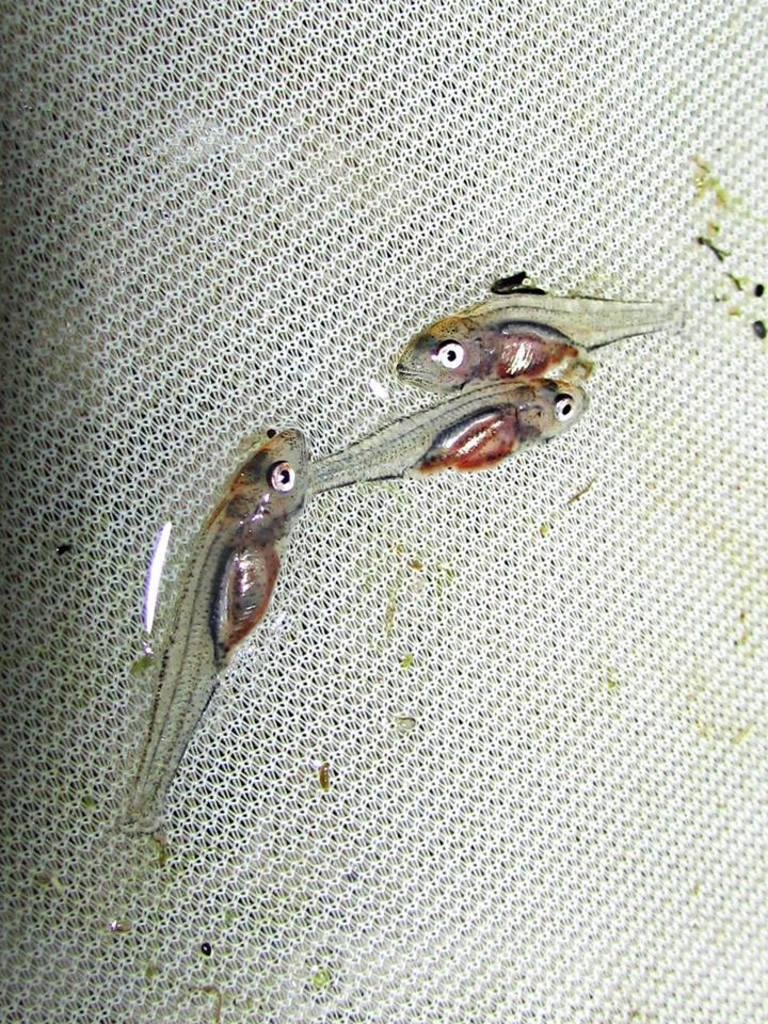What type of animals can be seen in the picture? There are fishes in the picture. What is the background or surface on which the fishes are placed? The fishes are placed on a white surface. What type of wound can be seen on the fish in the picture? There is no wound visible on the fish in the picture, as the image only shows fishes placed on a white surface. 